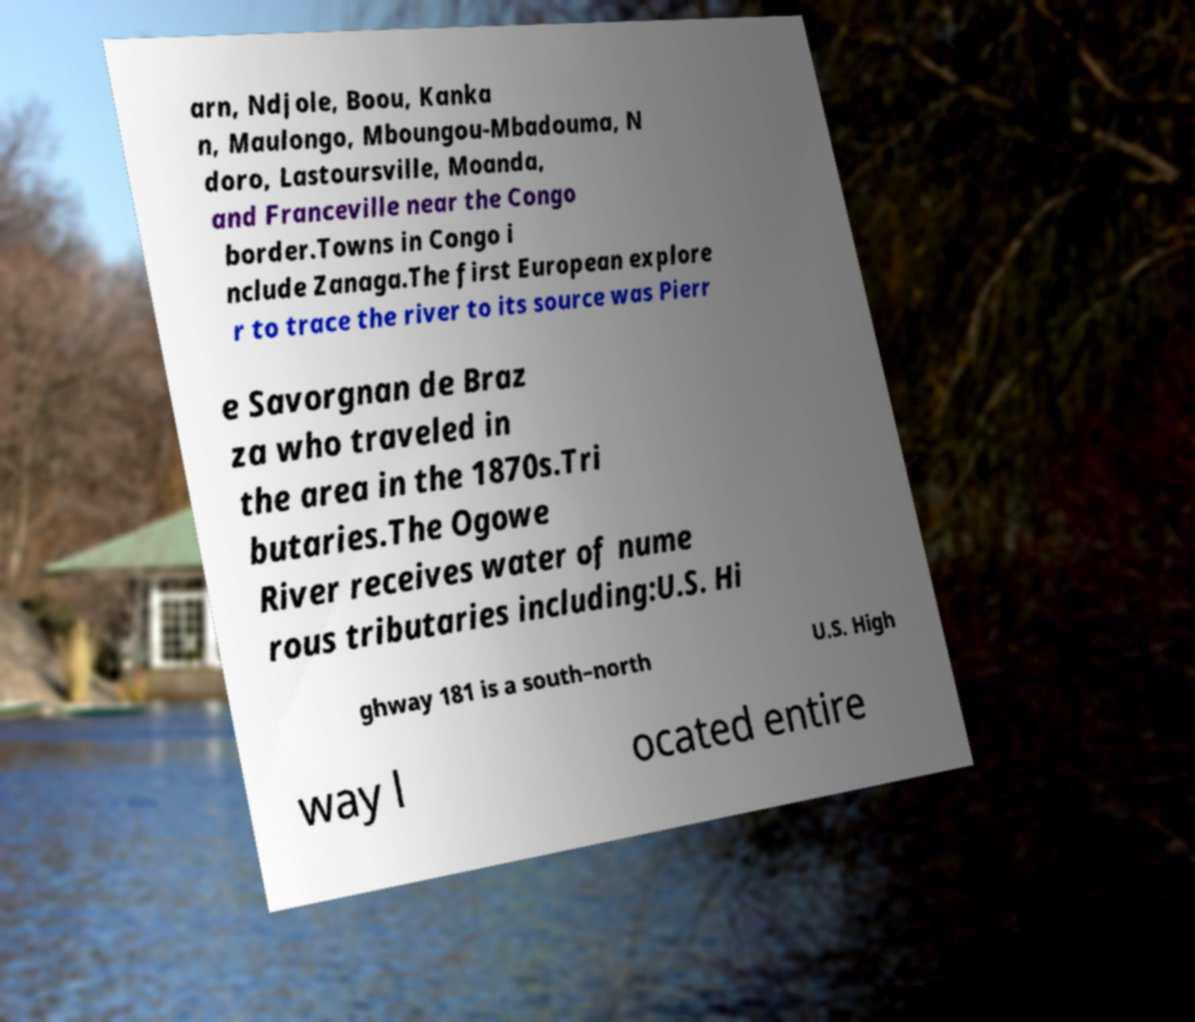Can you read and provide the text displayed in the image?This photo seems to have some interesting text. Can you extract and type it out for me? arn, Ndjole, Boou, Kanka n, Maulongo, Mboungou-Mbadouma, N doro, Lastoursville, Moanda, and Franceville near the Congo border.Towns in Congo i nclude Zanaga.The first European explore r to trace the river to its source was Pierr e Savorgnan de Braz za who traveled in the area in the 1870s.Tri butaries.The Ogowe River receives water of nume rous tributaries including:U.S. Hi ghway 181 is a south–north U.S. High way l ocated entire 